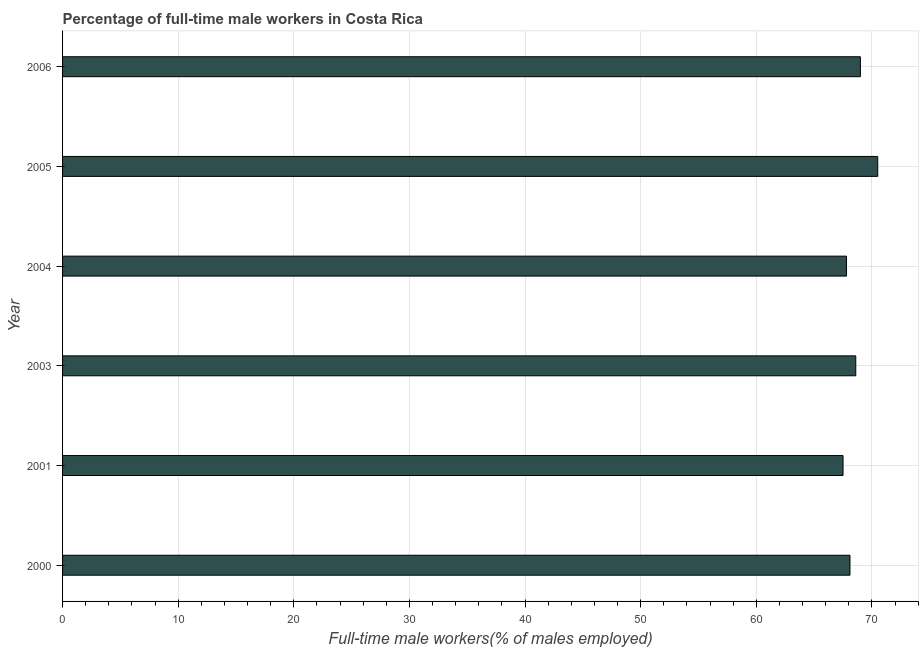Does the graph contain any zero values?
Your answer should be very brief. No. What is the title of the graph?
Make the answer very short. Percentage of full-time male workers in Costa Rica. What is the label or title of the X-axis?
Provide a short and direct response. Full-time male workers(% of males employed). What is the percentage of full-time male workers in 2000?
Offer a very short reply. 68.1. Across all years, what is the maximum percentage of full-time male workers?
Keep it short and to the point. 70.5. Across all years, what is the minimum percentage of full-time male workers?
Your answer should be very brief. 67.5. In which year was the percentage of full-time male workers maximum?
Keep it short and to the point. 2005. In which year was the percentage of full-time male workers minimum?
Your answer should be compact. 2001. What is the sum of the percentage of full-time male workers?
Offer a terse response. 411.5. What is the difference between the percentage of full-time male workers in 2001 and 2004?
Your response must be concise. -0.3. What is the average percentage of full-time male workers per year?
Your answer should be very brief. 68.58. What is the median percentage of full-time male workers?
Your response must be concise. 68.35. In how many years, is the percentage of full-time male workers greater than 40 %?
Ensure brevity in your answer.  6. Do a majority of the years between 2001 and 2005 (inclusive) have percentage of full-time male workers greater than 12 %?
Keep it short and to the point. Yes. Is the difference between the percentage of full-time male workers in 2004 and 2006 greater than the difference between any two years?
Ensure brevity in your answer.  No. What is the difference between the highest and the second highest percentage of full-time male workers?
Provide a short and direct response. 1.5. Is the sum of the percentage of full-time male workers in 2003 and 2006 greater than the maximum percentage of full-time male workers across all years?
Your answer should be compact. Yes. What is the difference between the highest and the lowest percentage of full-time male workers?
Your answer should be compact. 3. How many bars are there?
Your answer should be very brief. 6. Are all the bars in the graph horizontal?
Ensure brevity in your answer.  Yes. How many years are there in the graph?
Your response must be concise. 6. Are the values on the major ticks of X-axis written in scientific E-notation?
Your answer should be compact. No. What is the Full-time male workers(% of males employed) in 2000?
Keep it short and to the point. 68.1. What is the Full-time male workers(% of males employed) of 2001?
Provide a succinct answer. 67.5. What is the Full-time male workers(% of males employed) in 2003?
Make the answer very short. 68.6. What is the Full-time male workers(% of males employed) of 2004?
Your answer should be compact. 67.8. What is the Full-time male workers(% of males employed) of 2005?
Make the answer very short. 70.5. What is the Full-time male workers(% of males employed) of 2006?
Your answer should be very brief. 69. What is the difference between the Full-time male workers(% of males employed) in 2000 and 2001?
Ensure brevity in your answer.  0.6. What is the difference between the Full-time male workers(% of males employed) in 2000 and 2004?
Make the answer very short. 0.3. What is the difference between the Full-time male workers(% of males employed) in 2000 and 2006?
Make the answer very short. -0.9. What is the difference between the Full-time male workers(% of males employed) in 2001 and 2005?
Give a very brief answer. -3. What is the difference between the Full-time male workers(% of males employed) in 2003 and 2004?
Ensure brevity in your answer.  0.8. What is the difference between the Full-time male workers(% of males employed) in 2003 and 2006?
Your response must be concise. -0.4. What is the difference between the Full-time male workers(% of males employed) in 2004 and 2005?
Your answer should be compact. -2.7. What is the difference between the Full-time male workers(% of males employed) in 2005 and 2006?
Keep it short and to the point. 1.5. What is the ratio of the Full-time male workers(% of males employed) in 2000 to that in 2005?
Give a very brief answer. 0.97. What is the ratio of the Full-time male workers(% of males employed) in 2000 to that in 2006?
Provide a succinct answer. 0.99. What is the ratio of the Full-time male workers(% of males employed) in 2001 to that in 2003?
Ensure brevity in your answer.  0.98. What is the ratio of the Full-time male workers(% of males employed) in 2001 to that in 2006?
Your answer should be compact. 0.98. What is the ratio of the Full-time male workers(% of males employed) in 2003 to that in 2004?
Your answer should be very brief. 1.01. What is the ratio of the Full-time male workers(% of males employed) in 2003 to that in 2005?
Offer a very short reply. 0.97. What is the ratio of the Full-time male workers(% of males employed) in 2003 to that in 2006?
Keep it short and to the point. 0.99. What is the ratio of the Full-time male workers(% of males employed) in 2004 to that in 2006?
Provide a short and direct response. 0.98. What is the ratio of the Full-time male workers(% of males employed) in 2005 to that in 2006?
Give a very brief answer. 1.02. 